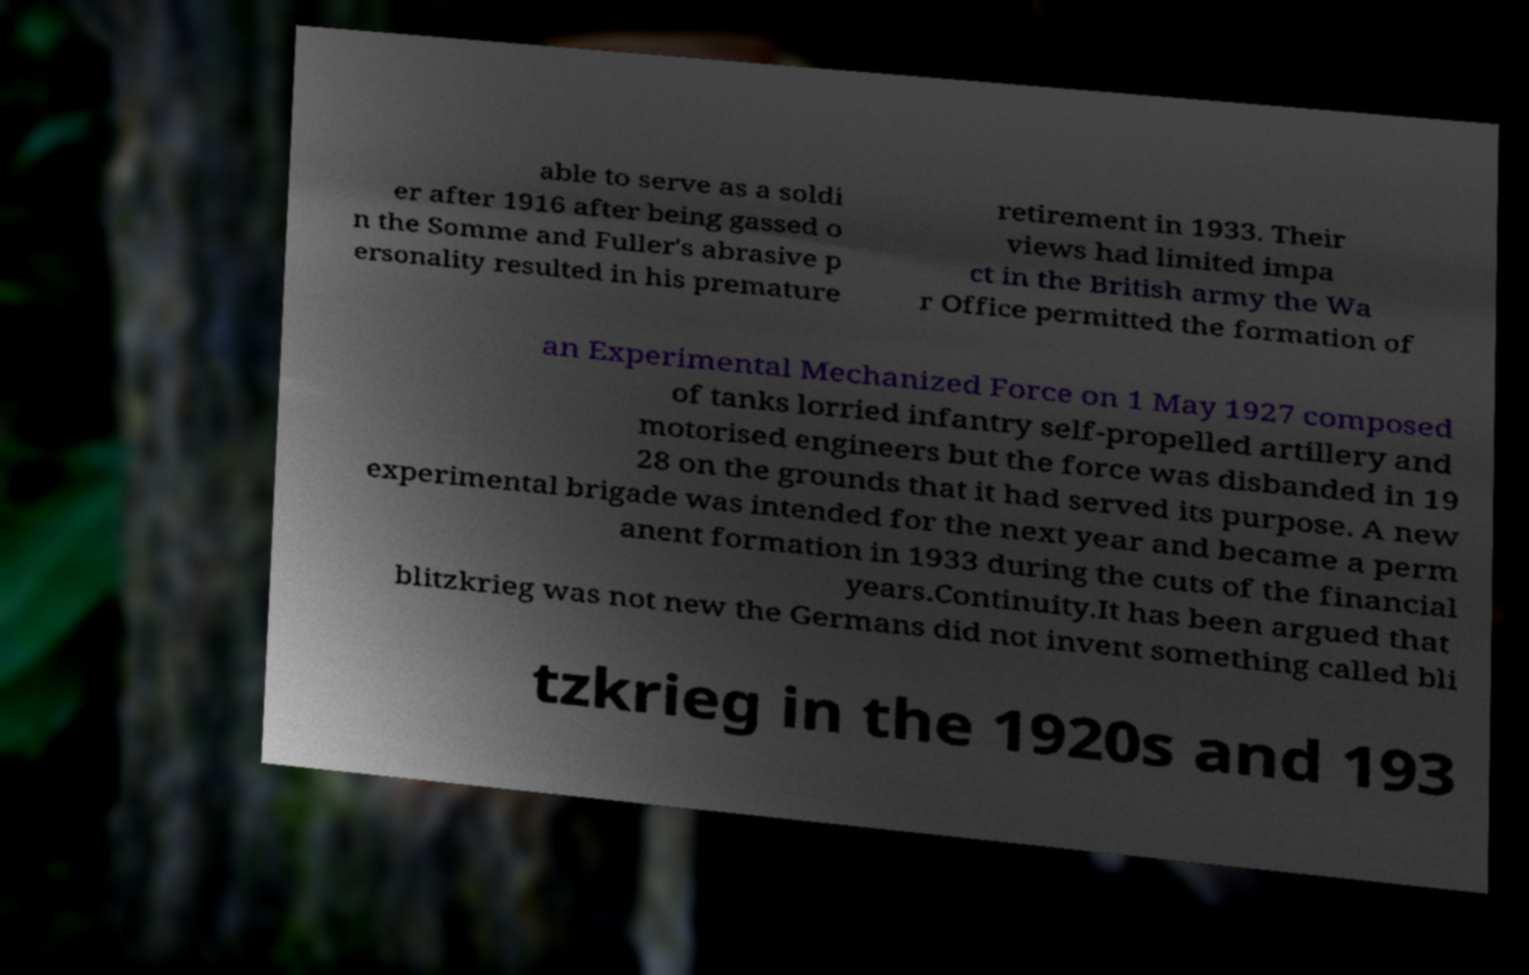Can you read and provide the text displayed in the image?This photo seems to have some interesting text. Can you extract and type it out for me? able to serve as a soldi er after 1916 after being gassed o n the Somme and Fuller's abrasive p ersonality resulted in his premature retirement in 1933. Their views had limited impa ct in the British army the Wa r Office permitted the formation of an Experimental Mechanized Force on 1 May 1927 composed of tanks lorried infantry self-propelled artillery and motorised engineers but the force was disbanded in 19 28 on the grounds that it had served its purpose. A new experimental brigade was intended for the next year and became a perm anent formation in 1933 during the cuts of the financial years.Continuity.It has been argued that blitzkrieg was not new the Germans did not invent something called bli tzkrieg in the 1920s and 193 